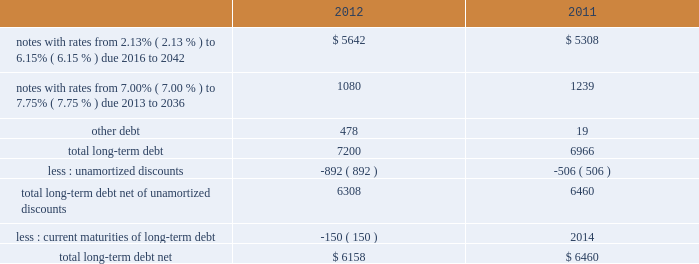Note 8 2013 debt our long-term debt consisted of the following ( in millions ) : .
In december 2012 , we issued notes totaling $ 1.3 billion with a fixed interest rate of 4.07% ( 4.07 % ) maturing in december 2042 ( the new notes ) in exchange for outstanding notes totaling $ 1.2 billion with interest rates ranging from 5.50% ( 5.50 % ) to 8.50% ( 8.50 % ) maturing in 2023 to 2040 ( the old notes ) .
In connection with the exchange , we paid a premium of $ 393 million , of which $ 225 million was paid in cash and $ 168 million was in the form of new notes .
This premium , in addition to $ 194 million in remaining unamortized discounts related to the old notes , will be amortized as additional interest expense over the term of the new notes using the effective interest method .
We may , at our option , redeem some or all of the new notes at any time by paying the principal amount of notes being redeemed plus a make-whole premium and accrued and unpaid interest .
Interest on the new notes is payable on june 15 and december 15 of each year , beginning on june 15 , 2013 .
The new notes are unsecured senior obligations and rank equally in right of payment with all of our existing and future unsecured and unsubordinated indebtedness .
On september 9 , 2011 , we issued $ 2.0 billion of long-term notes in a registered public offering consisting of $ 500 million maturing in 2016 with a fixed interest rate of 2.13% ( 2.13 % ) , $ 900 million maturing in 2021 with a fixed interest rate of 3.35% ( 3.35 % ) , and $ 600 million maturing in 2041 with a fixed interest rate of 4.85% ( 4.85 % ) .
We may , at our option , redeem some or all of the notes at any time by paying the principal amount of notes being redeemed plus a make-whole premium and accrued and unpaid interest .
Interest on the notes is payable on march 15 and september 15 of each year , beginning on march 15 , 2012 .
In october 2011 , we used a portion of the proceeds to redeem all of our $ 500 million long-term notes maturing in 2013 .
In 2011 , we repurchased $ 84 million of our long-term notes through open-market purchases .
We paid premiums of $ 48 million in connection with the early extinguishments of debt , which were recognized in other non-operating income ( expense ) , net .
In august 2011 , we entered into a $ 1.5 billion revolving credit facility with a group of banks and terminated our existing $ 1.5 billion revolving credit facility that was to expire in june 2012 .
The credit facility expires august 2016 , and we may request and the banks may grant , at their discretion , an increase to the credit facility by an additional amount up to $ 500 million .
There were no borrowings outstanding under either facility through december 31 , 2012 .
Borrowings under the credit facility would be unsecured and bear interest at rates based , at our option , on a eurodollar rate or a base rate , as defined in the credit facility .
Each bank 2019s obligation to make loans under the credit facility is subject to , among other things , our compliance with various representations , warranties and covenants , including covenants limiting our ability and certain of our subsidiaries 2019 ability to encumber assets and a covenant not to exceed a maximum leverage ratio , as defined in the credit facility .
The leverage ratio covenant excludes the adjustments recognized in stockholders 2019 equity related to postretirement benefit plans .
As of december 31 , 2012 , we were in compliance with all covenants contained in the credit facility , as well as in our debt agreements .
We have agreements in place with banking institutions to provide for the issuance of commercial paper .
There were no commercial paper borrowings outstanding during 2012 or 2011 .
If we were to issue commercial paper , the borrowings would be supported by the credit facility .
During the next five years , we have scheduled long-term debt maturities of $ 150 million due in 2013 and $ 952 million due in 2016 .
Interest payments were $ 378 million in 2012 , $ 326 million in 2011 , and $ 337 million in 2010. .
What is the percentage change in interest payments from 2010 to 2011? 
Computations: ((326 - 337) / 337)
Answer: -0.03264. 